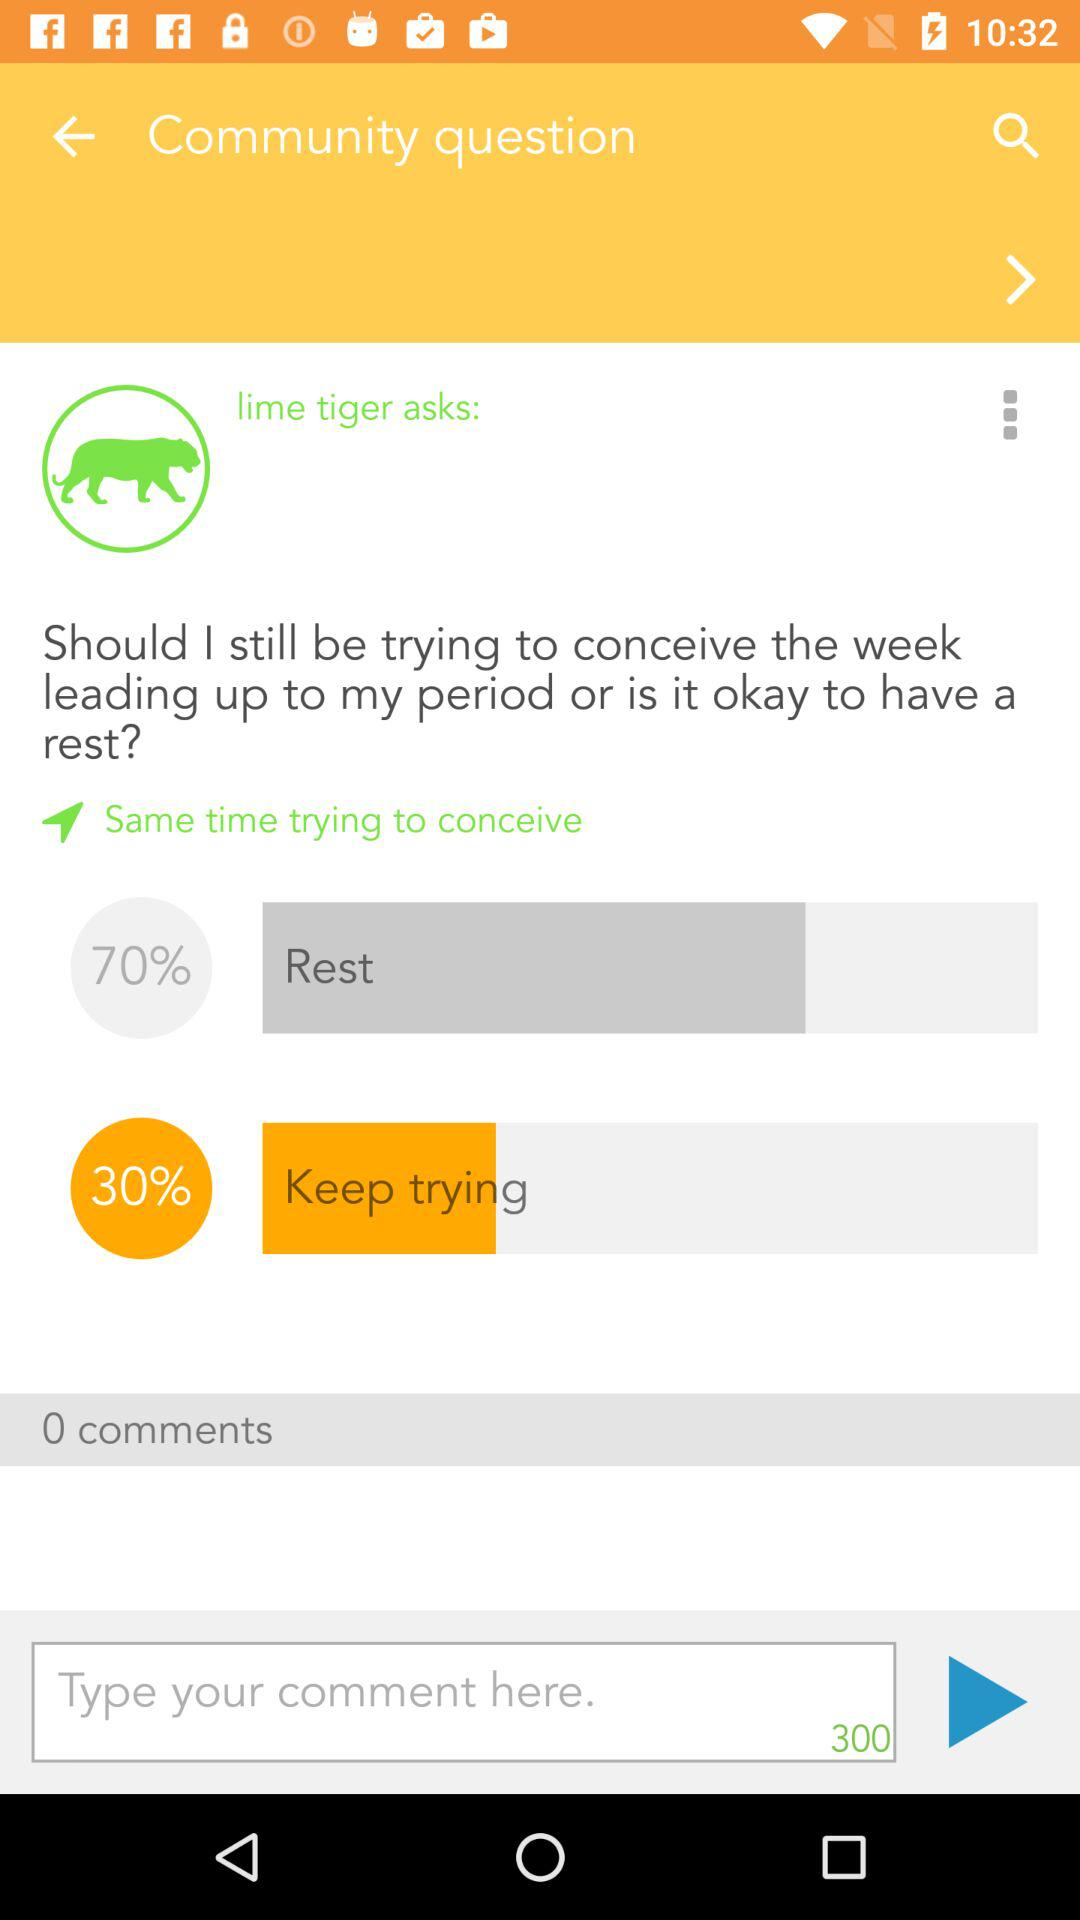How many words did the user type into their comment?
When the provided information is insufficient, respond with <no answer>. <no answer> 